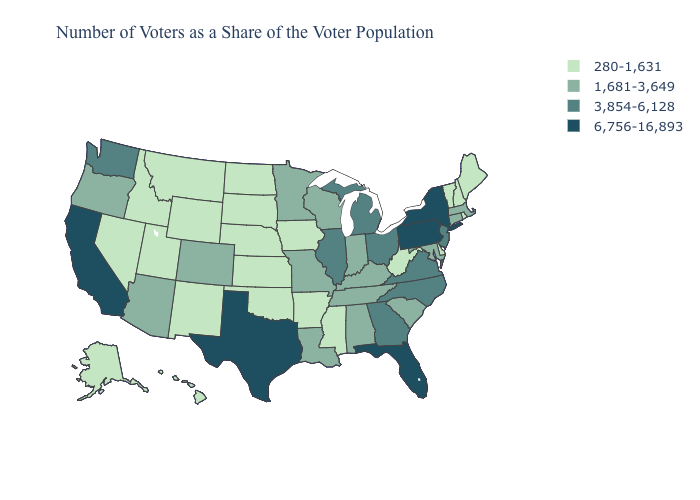Name the states that have a value in the range 3,854-6,128?
Keep it brief. Georgia, Illinois, Michigan, New Jersey, North Carolina, Ohio, Virginia, Washington. Name the states that have a value in the range 1,681-3,649?
Short answer required. Alabama, Arizona, Colorado, Connecticut, Indiana, Kentucky, Louisiana, Maryland, Massachusetts, Minnesota, Missouri, Oregon, South Carolina, Tennessee, Wisconsin. Does Utah have the lowest value in the USA?
Give a very brief answer. Yes. Name the states that have a value in the range 1,681-3,649?
Keep it brief. Alabama, Arizona, Colorado, Connecticut, Indiana, Kentucky, Louisiana, Maryland, Massachusetts, Minnesota, Missouri, Oregon, South Carolina, Tennessee, Wisconsin. Among the states that border Minnesota , does Wisconsin have the lowest value?
Be succinct. No. What is the highest value in the West ?
Short answer required. 6,756-16,893. Which states hav the highest value in the MidWest?
Keep it brief. Illinois, Michigan, Ohio. Among the states that border Iowa , does Illinois have the highest value?
Give a very brief answer. Yes. Name the states that have a value in the range 1,681-3,649?
Write a very short answer. Alabama, Arizona, Colorado, Connecticut, Indiana, Kentucky, Louisiana, Maryland, Massachusetts, Minnesota, Missouri, Oregon, South Carolina, Tennessee, Wisconsin. Does South Carolina have the lowest value in the South?
Give a very brief answer. No. Among the states that border North Carolina , which have the highest value?
Keep it brief. Georgia, Virginia. Does Pennsylvania have the lowest value in the USA?
Be succinct. No. What is the value of New Jersey?
Concise answer only. 3,854-6,128. What is the value of Washington?
Write a very short answer. 3,854-6,128. Name the states that have a value in the range 1,681-3,649?
Answer briefly. Alabama, Arizona, Colorado, Connecticut, Indiana, Kentucky, Louisiana, Maryland, Massachusetts, Minnesota, Missouri, Oregon, South Carolina, Tennessee, Wisconsin. 